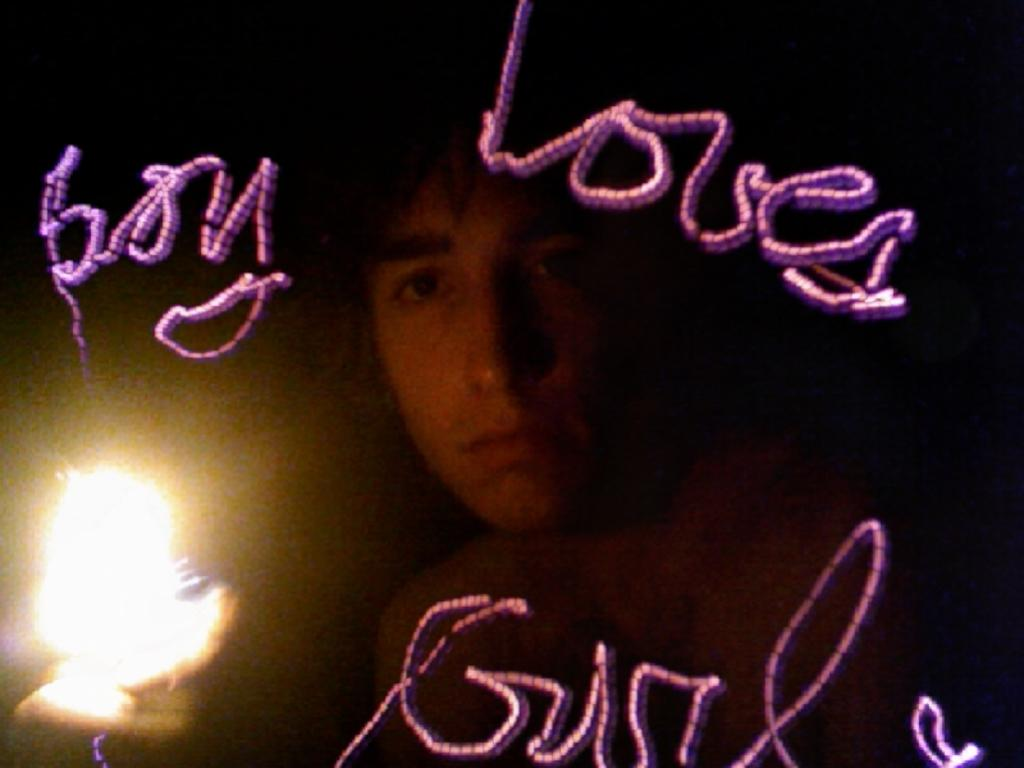How many people are in the image? There is one person in the image. What can be seen on the surface in the image? There is a light on the surface in the image. What else is present in the image besides the person and the light? There is text present in the image. Is there a volcano erupting in the background of the image? No, there is no volcano present in the image. How many basins are visible in the image? There is no basin present in the image. 